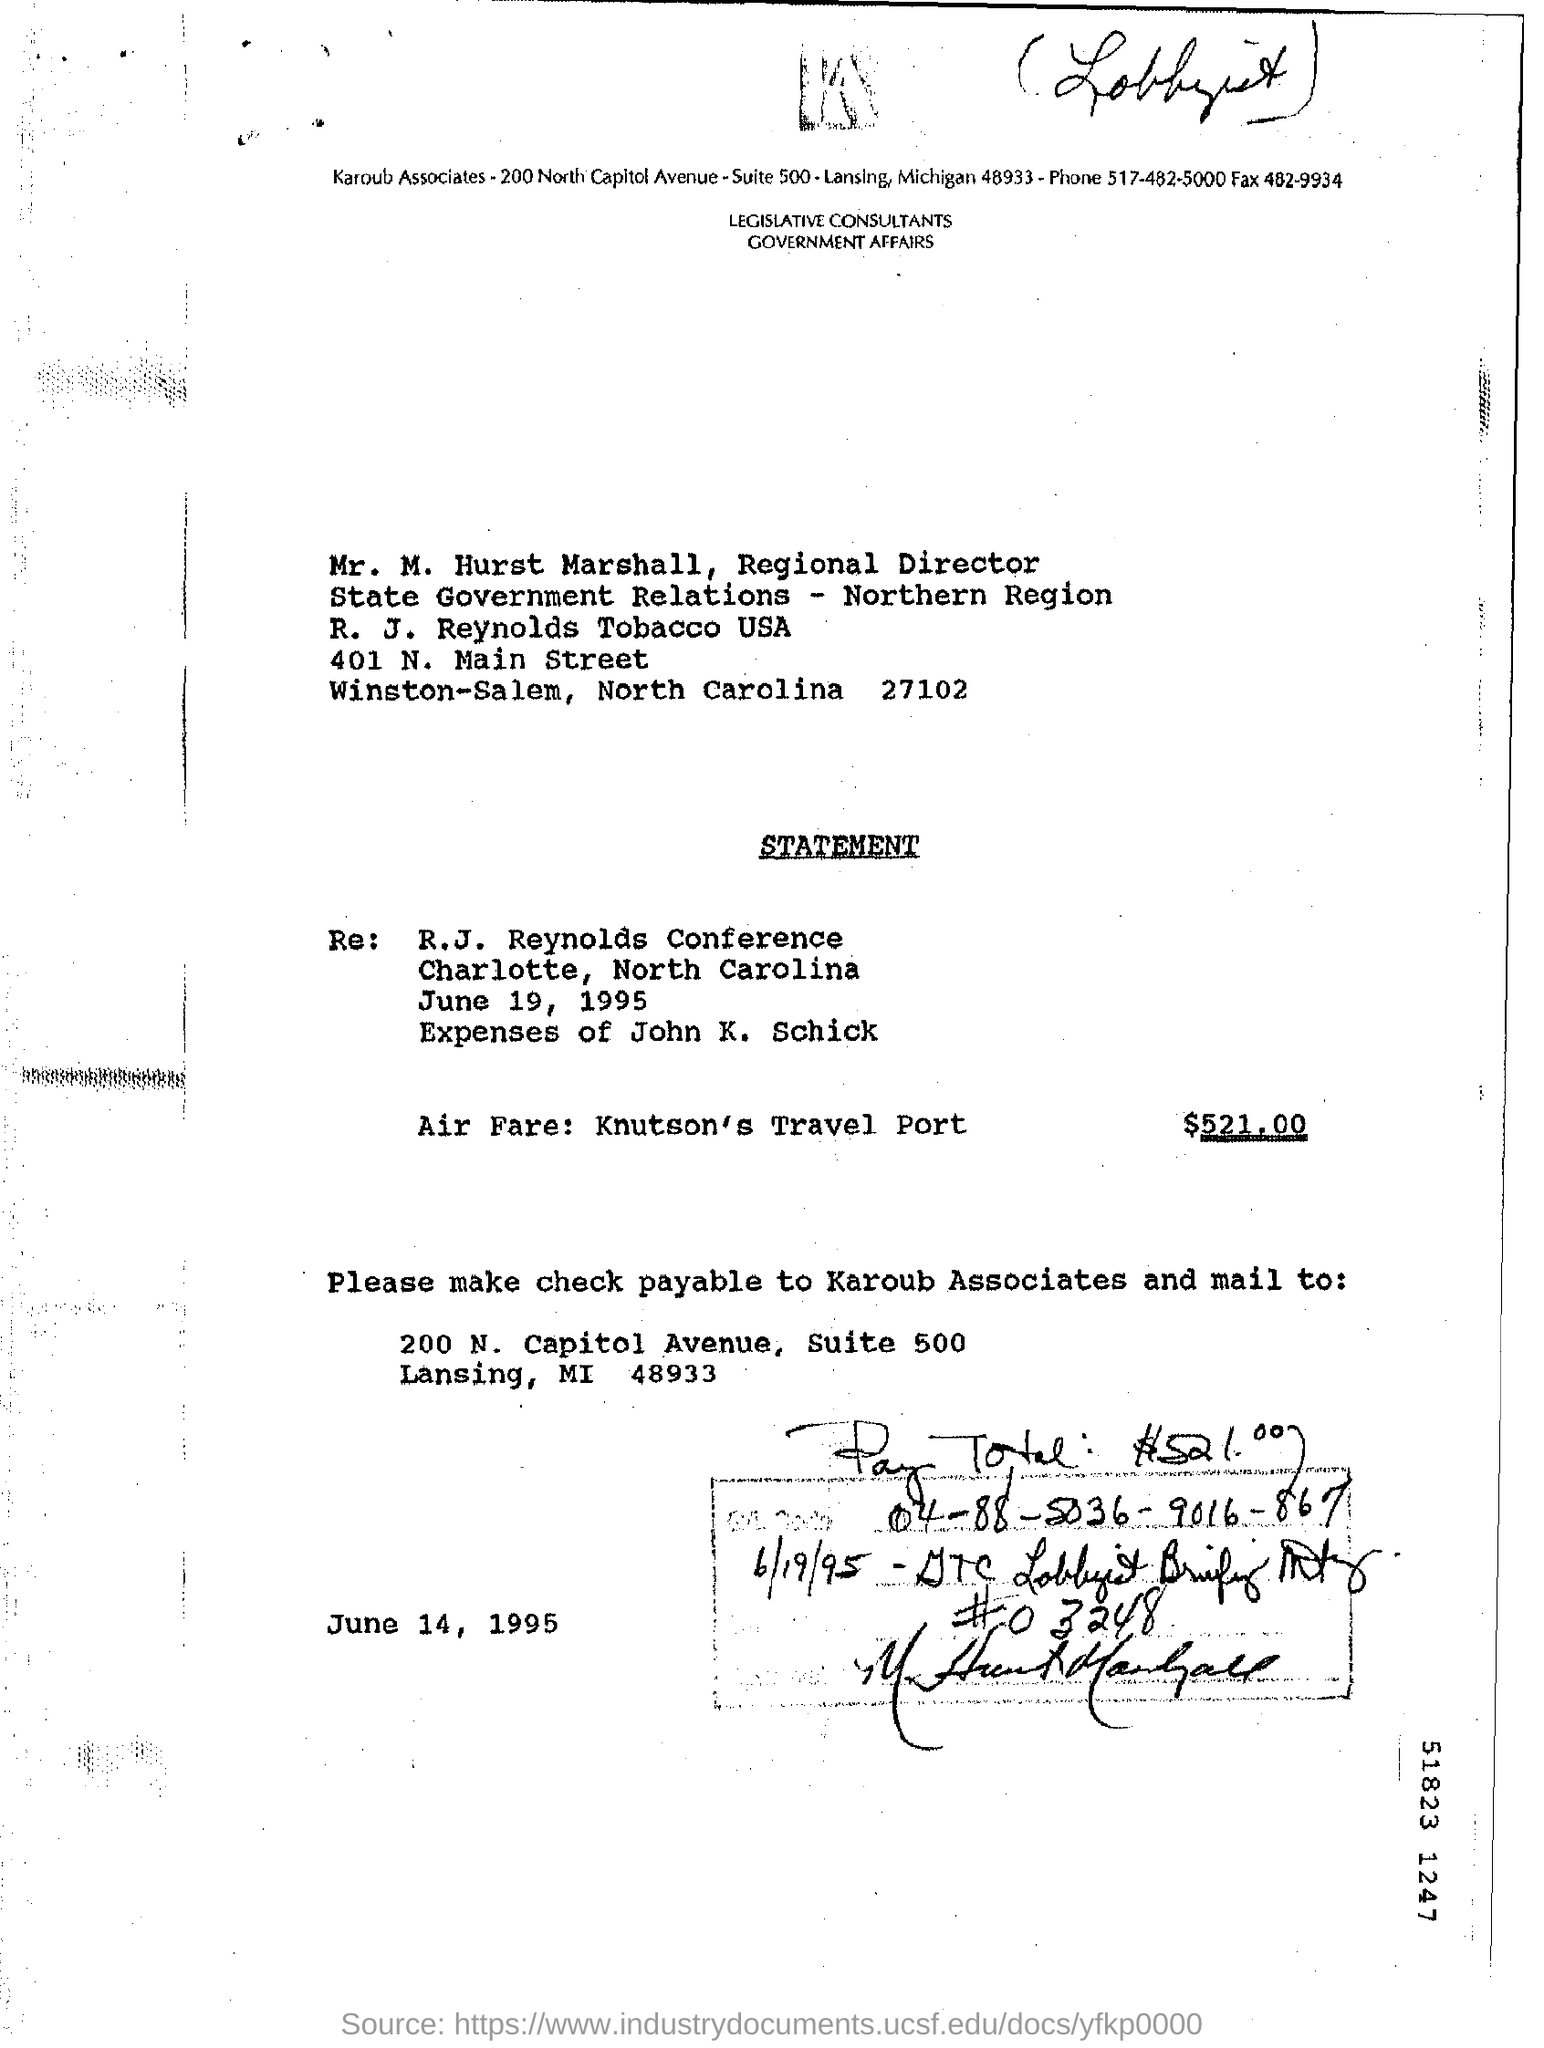Indicate a few pertinent items in this graphic. The check is payable to Karoub Associates. The air fare is $521.00. The letter is dated June 14, 1995. 